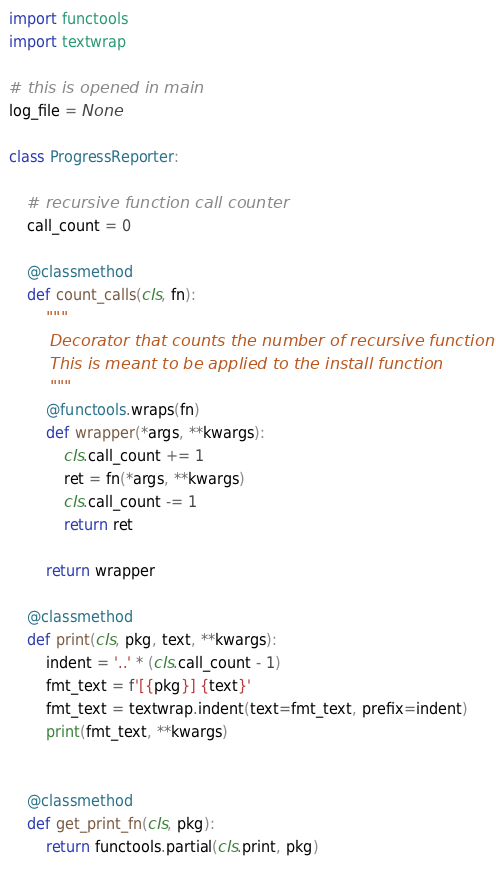Convert code to text. <code><loc_0><loc_0><loc_500><loc_500><_Python_>import functools
import textwrap

# this is opened in main
log_file = None

class ProgressReporter:

    # recursive function call counter
    call_count = 0

    @classmethod
    def count_calls(cls, fn):
        """
        Decorator that counts the number of recursive function calls.
        This is meant to be applied to the install function
        """
        @functools.wraps(fn)
        def wrapper(*args, **kwargs):
            cls.call_count += 1
            ret = fn(*args, **kwargs)
            cls.call_count -= 1
            return ret
    
        return wrapper

    @classmethod
    def print(cls, pkg, text, **kwargs):
        indent = '..' * (cls.call_count - 1)
        fmt_text = f'[{pkg}] {text}'
        fmt_text = textwrap.indent(text=fmt_text, prefix=indent)
        print(fmt_text, **kwargs)

    
    @classmethod
    def get_print_fn(cls, pkg):
        return functools.partial(cls.print, pkg)</code> 